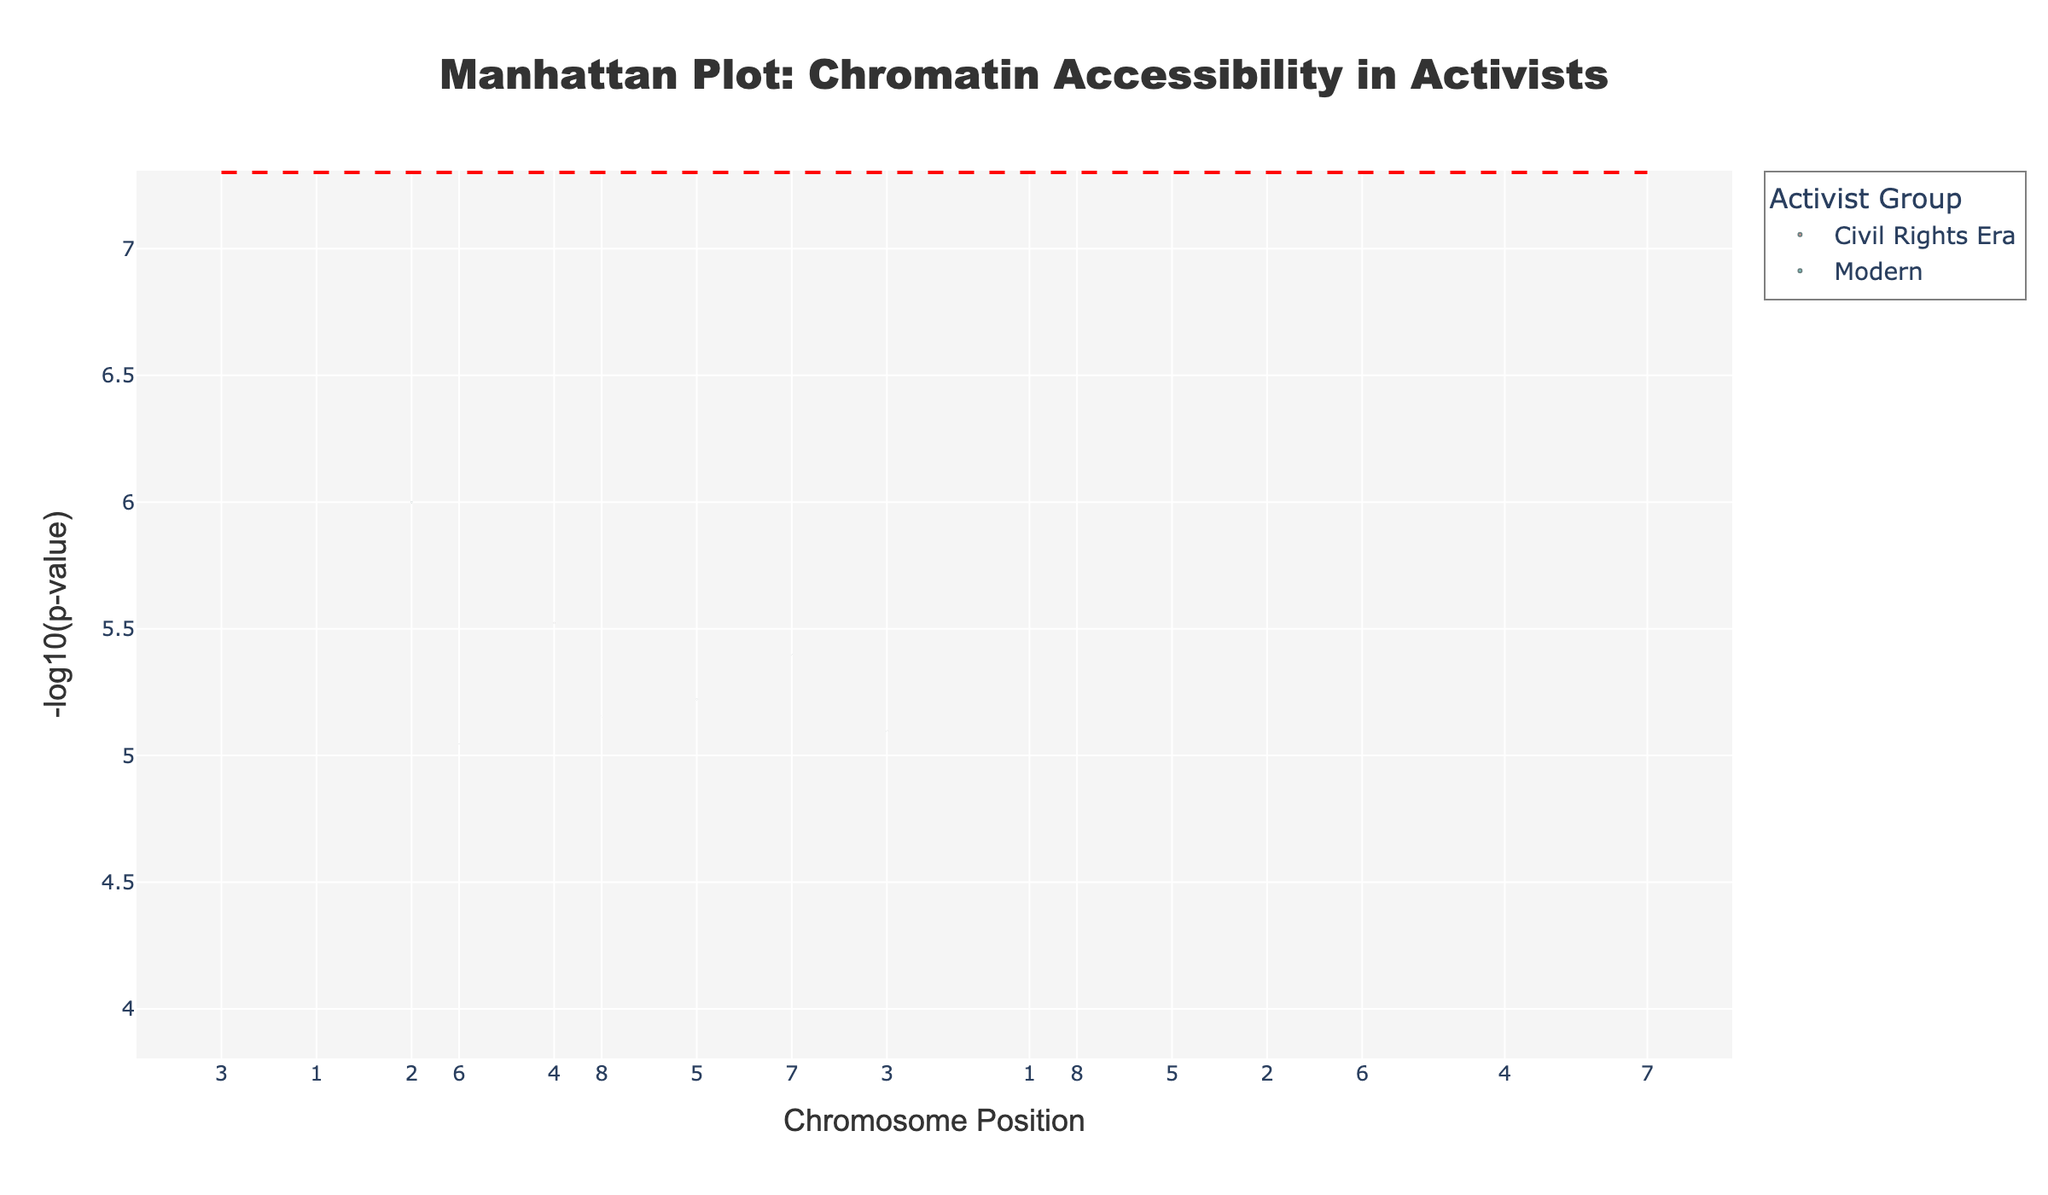What is the title of the plot? The title of the plot is positioned at the top and clearly states what the plot represents, it reads: "Manhattan Plot: Chromatin Accessibility in Activists"
Answer: Manhattan Plot: Chromatin Accessibility in Activists How is the P-value represented on the y-axis? The y-axis represents the P-value as -log10(p-value). This is a standard way to make very small P-values more interpretable on a plot.
Answer: -log10(p-value) Which group has the highest -log10(p-value)? To identify the group with the highest -log10(p-value), look at the highest point on the y-axis and see its corresponding group from the legend or the hover text. The highest -log10(p-value) is at chromosome position 1200000 and corresponds to the 'Civil Rights Era' group.
Answer: Civil Rights Era How does the plot distinguish between the two groups of activists? The plot uses different colors for data points representing different groups: '#FF6B6B' for the Civil Rights Era and '#4ECDC4' for the Modern group. These colors help identify the associations belonging to each group clearly.
Answer: Different colors What is the chromosome position of the data point with the lowest P-value (highest -log10(p-value))? To find the position with the lowest P-value (highest -log10(p-value)), locate the highest point on the y-axis. This marker is at position 1200000 on chromosome 2.
Answer: 1200000 Which gene has the smallest P-value (highest -log10(p-value)) and which group does it belong to? The gene with the smallest P-value will correspond to the highest -log10(p-value) on the plot. Hover over the highest point to see the gene name and its group. This is the gene COMT, and it belongs to the Civil Rights Era group.
Answer: COMT, Civil Rights Era What is the significance threshold line and where is it placed on the plot? The significance threshold line is a horizontal dashed line across the plot placed at y = -log10(5e-8), which is a common genome-wide significance level in Manhattan plots.
Answer: At y = -log10(5e-8) Are there more significant genes identified in the Civil Rights Era or Modern group after applying the significance threshold? Significance is indicated by data points lying above the horizontal threshold line. There are more points above this line in the 'Civil Rights Era' group compared to the 'Modern' group.
Answer: Civil Rights Era Which chromosome has the most data points in the plot? Count the data points along different chromosome tick labels on the x-axis. Chromosome 1 has the most data points as it has two data points from both groups.
Answer: Chromosome 1 